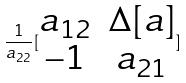Convert formula to latex. <formula><loc_0><loc_0><loc_500><loc_500>\frac { 1 } { a _ { 2 2 } } [ \begin{matrix} a _ { 1 2 } & \Delta [ a ] \\ - 1 & a _ { 2 1 } \end{matrix} ]</formula> 